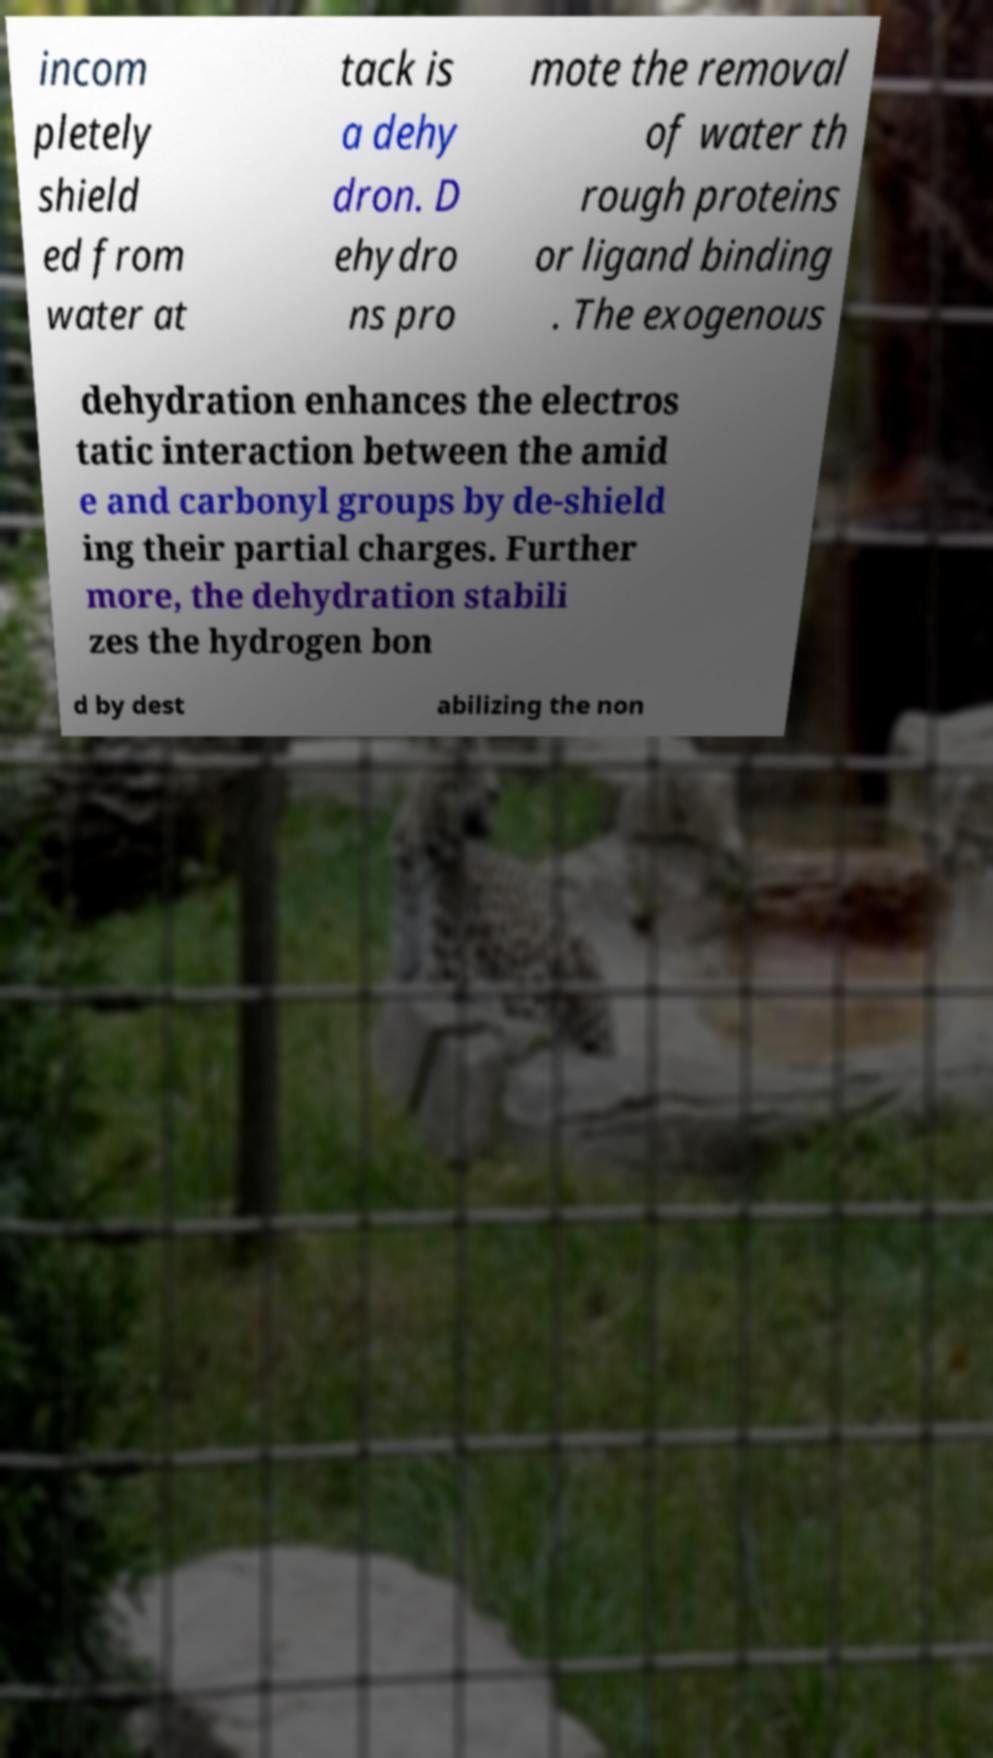What messages or text are displayed in this image? I need them in a readable, typed format. incom pletely shield ed from water at tack is a dehy dron. D ehydro ns pro mote the removal of water th rough proteins or ligand binding . The exogenous dehydration enhances the electros tatic interaction between the amid e and carbonyl groups by de-shield ing their partial charges. Further more, the dehydration stabili zes the hydrogen bon d by dest abilizing the non 